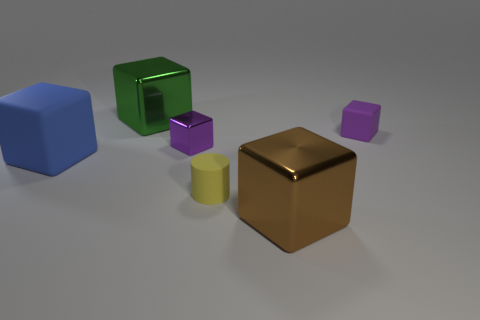Subtract all large green cubes. How many cubes are left? 4 Subtract all brown cubes. How many cubes are left? 4 Subtract 1 cubes. How many cubes are left? 4 Subtract all red cubes. Subtract all cyan cylinders. How many cubes are left? 5 Add 1 brown metal cubes. How many objects exist? 7 Subtract all cylinders. How many objects are left? 5 Subtract 0 brown balls. How many objects are left? 6 Subtract all yellow matte blocks. Subtract all purple objects. How many objects are left? 4 Add 3 brown objects. How many brown objects are left? 4 Add 3 large green blocks. How many large green blocks exist? 4 